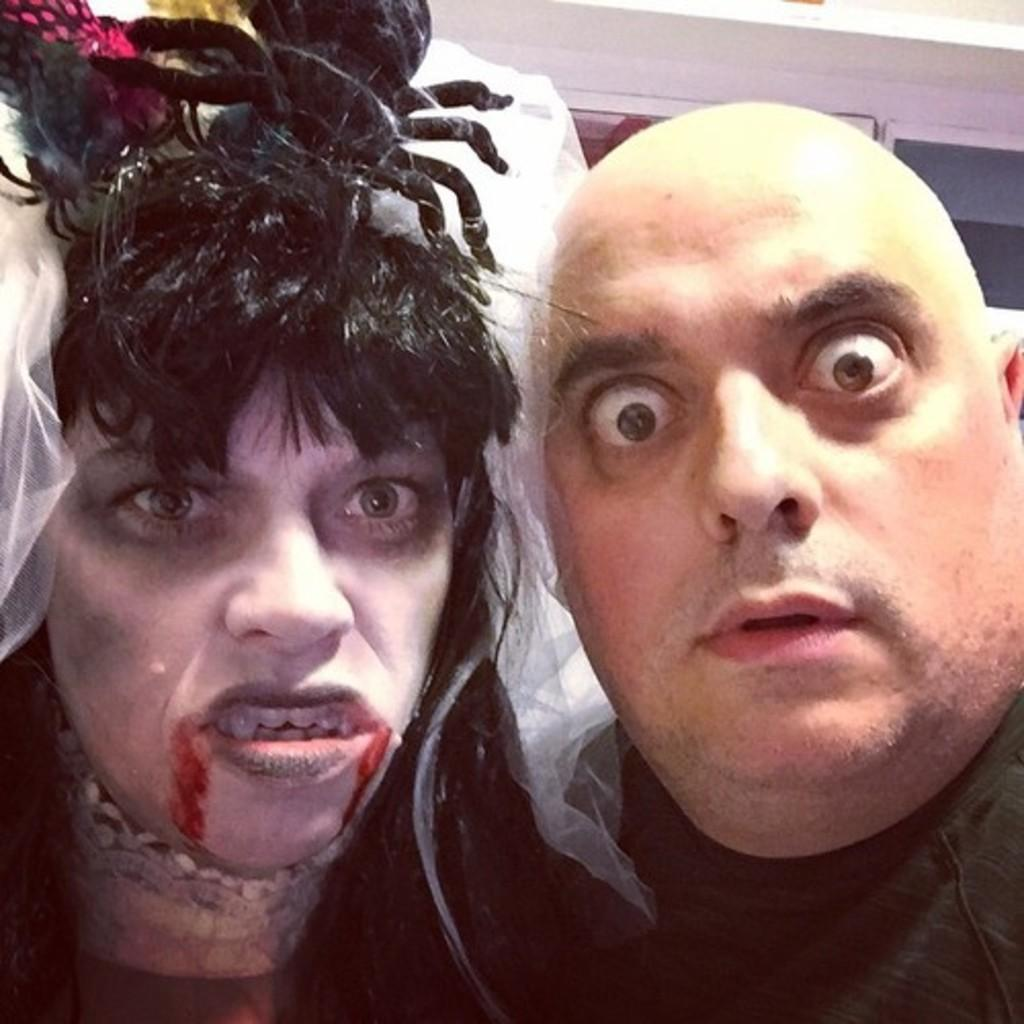How many people are in the image? There are two people in the image. What colors are the dresses worn by the people in the image? One person is wearing a white dress, and the other person is wearing a green dress. What can be seen in the background of the image? There is a wall visible in the background of the image. How many shoes can be seen on the wall in the image? There are no shoes visible on the wall in the image. What type of fold can be seen in the white dress in the image? There is no fold visible in the white dress in the image. 